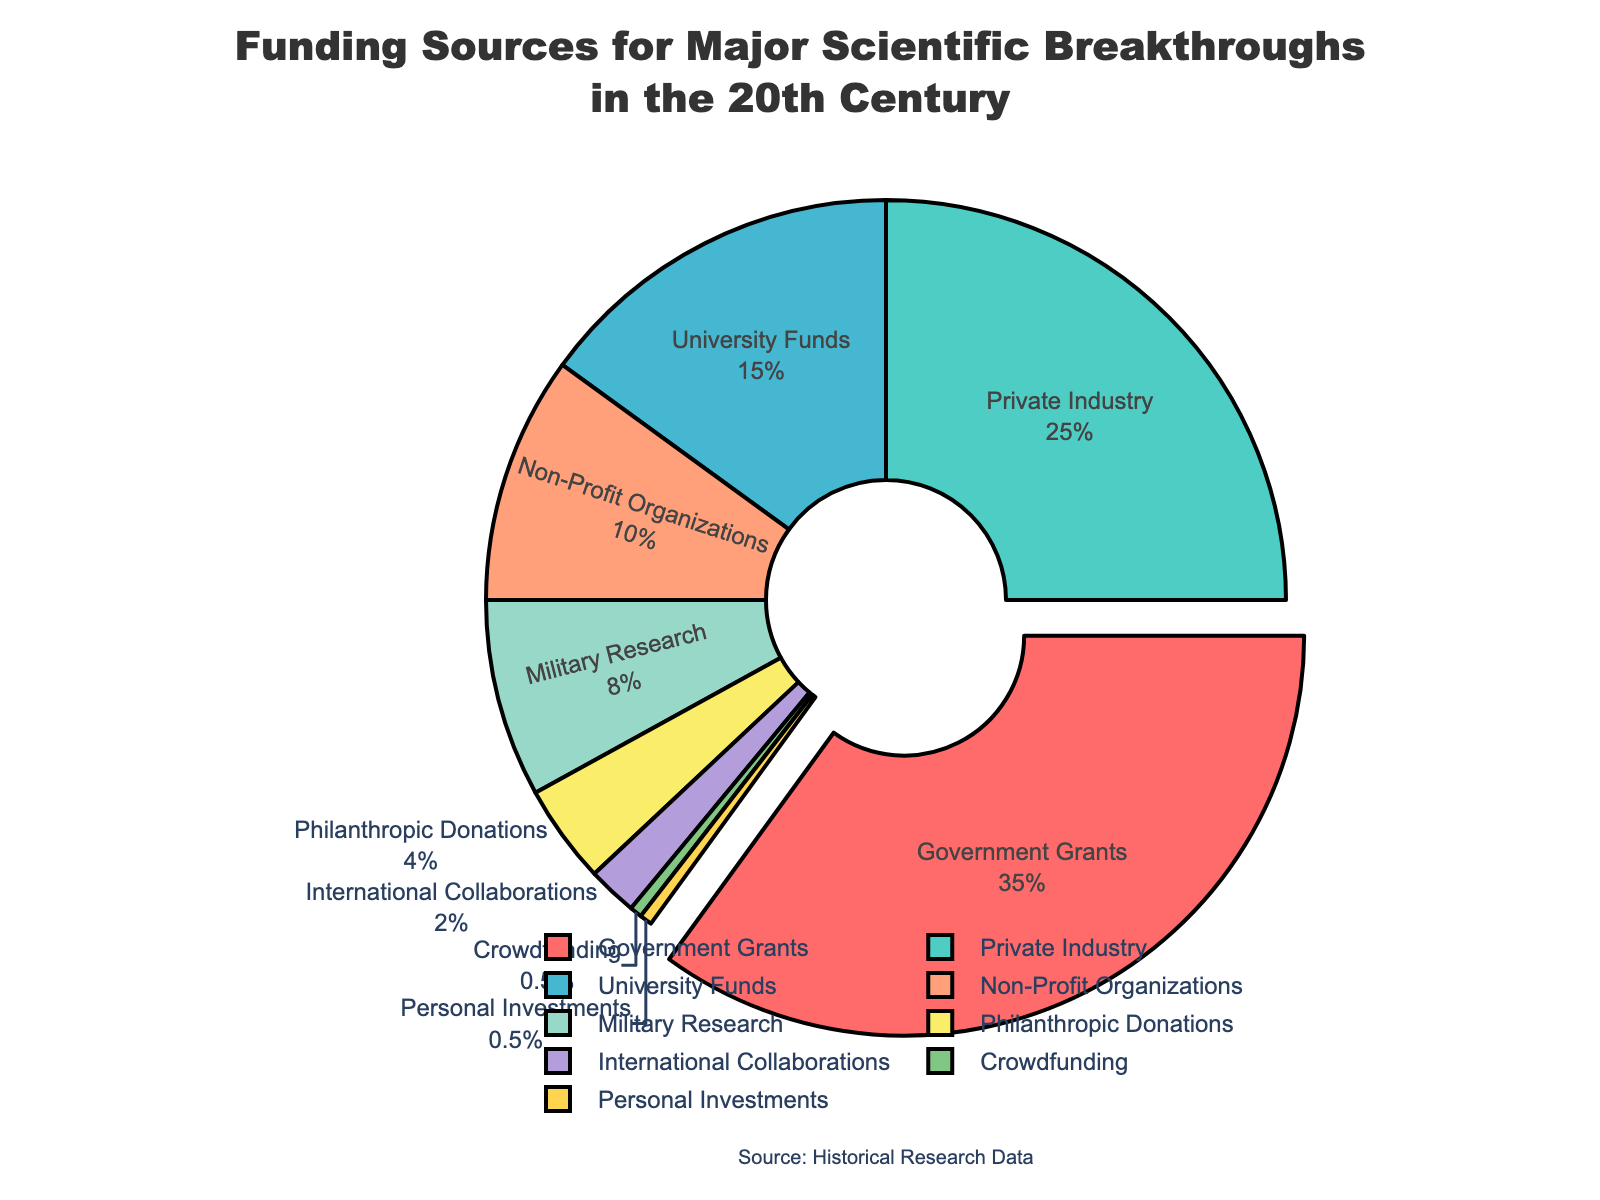Which funding source contributed the most to scientific breakthroughs in the 20th century? The funding source with the largest section of the pie chart represents the most significant contribution. The chart highlights "Government Grants" in a pulled-out segment, indicating it as the largest contributor.
Answer: Government Grants Which funding sources together contribute more than 50% of the total funding? By summing the percentages of the leading sources starting from the largest, determine when the total exceeds 50%. Government Grants (35%) + Private Industry (25%) = 60%, which is more than half.
Answer: Government Grants, Private Industry What is the combined percentage contribution from University Funds, Non-Profit Organizations, and Military Research? Add the percentages for these sources: University Funds (15%) + Non-Profit Organizations (10%) + Military Research (8%) = 33%.
Answer: 33% Which funding source contributes the least to scientific breakthroughs in the 20th century? The funding source with the smallest portion of the pie chart represents the least contribution. The chart shows both Crowdfunding and Personal Investments each contributing 0.5%.
Answer: Crowdfunding, Personal Investments How does the percentage of Private Industry funding compare to Military Research funding? Compare the percentages directly from the chart: Private Industry (25%) is greater than Military Research (8%).
Answer: Private Industry is greater What is the visual difference between the sections for Non-Profit Organizations and Philanthropic Donations? Examine the colors and the size of the sections on the chart: Non-Profit Organizations' section is larger than Philanthropic Donations. Non-Profit Organizations are represented in a distinct color compared to Philanthropic Donations.
Answer: Non-Profit Organizations' section is larger What is the total percentage contribution of funding sources with contributions less than 10%? Add the percentages of the sources less than 10%: Non-Profit Organizations (10%) + Military Research (8%) + Philanthropic Donations (4%) + International Collaborations (2%) + Crowdfunding (0.5%) + Personal Investments (0.5%) = 25%.
Answer: 25% Which funding source appears in green color on the pie chart? Determine which section is colored green: Consulting the chart, Private Industry is displayed in green.
Answer: Private Industry How much more does Government Grants contribute compared to University Funds? Subtract the percentage of University Funds from Government Grants: 35% - 15% = 20%.
Answer: 20% more 